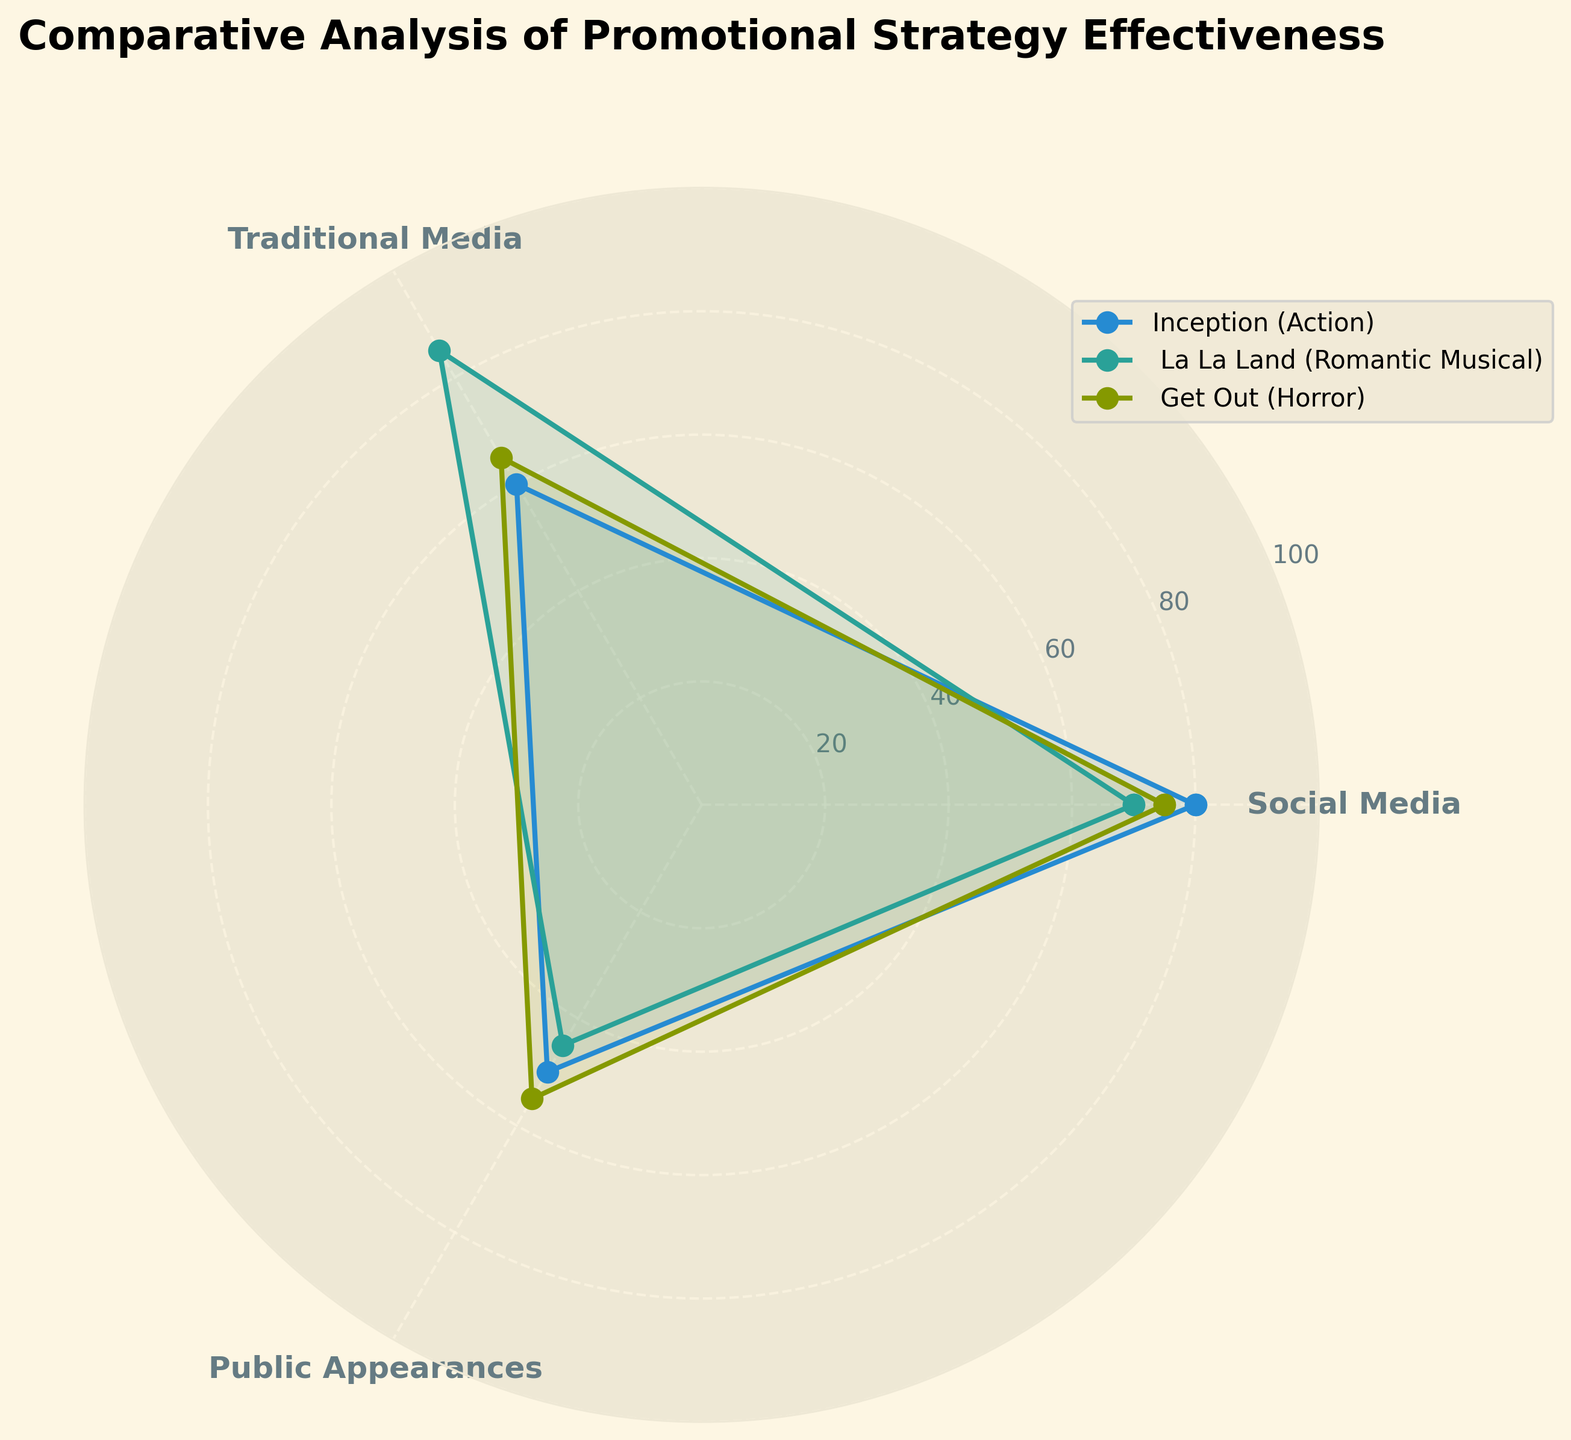How many promotional strategies are compared in the figure? The figure compares three promotional strategies. Each strategy corresponds to a different axis in the radar chart.
Answer: 3 Which movie has the highest effectiveness for Social Media? From the figure, look at the Social Media axis and see which movie's point is highest. Inception has a value of 80, which is the highest among the three movies for Social Media.
Answer: Inception Which promotional strategy is the least effective for La La Land? Check the plots for La La Land across all axes. The effectiveness values are 70 (Social Media), 85 (Traditional Media), and 45 (Public Appearances). Therefore, Public Appearances has the lowest value.
Answer: Public Appearances What is the average effectiveness score for Get Out across all promotional strategies? Adding up the effectiveness scores for Get Out: 75 (Social Media) + 65 (Traditional Media) + 55 (Public Appearances) = 195. Then, divide by 3 (the number of strategies): 195 / 3 = 65.
Answer: 65 Which movie has the largest range of effectiveness scores across the promotional strategies? Calculate the range (max value - min value) for each movie:
Inception: 80 - 50 = 30
La La Land: 85 - 45 = 40
Get Out: 75 - 55 = 20
La La Land has the highest range of 40.
Answer: La La Land Between Traditional Media and Public Appearances, which strategy is more effective for the average of the three movies combined? Calculate the averages for Traditional Media and Public Appearances:
Traditional Media: (60 + 85 + 65) / 3 = 70
Public Appearances: (50 + 45 + 55) / 3 = 50
Traditional Media has a higher average effectiveness of 70 compared to 50 for Public Appearances.
Answer: Traditional Media Which movie is most balanced in terms of promotional strategy effectiveness, having similar scores across all strategies? Check the range of effectiveness scores for each movie:
Inception: 80, 60, 50 (Range: 30)
La La Land: 70, 85, 45 (Range: 40)
Get Out: 75, 65, 55 (Range: 20)
Get Out has the smallest range of 20, indicating the most balanced effectiveness scores.
Answer: Get Out 